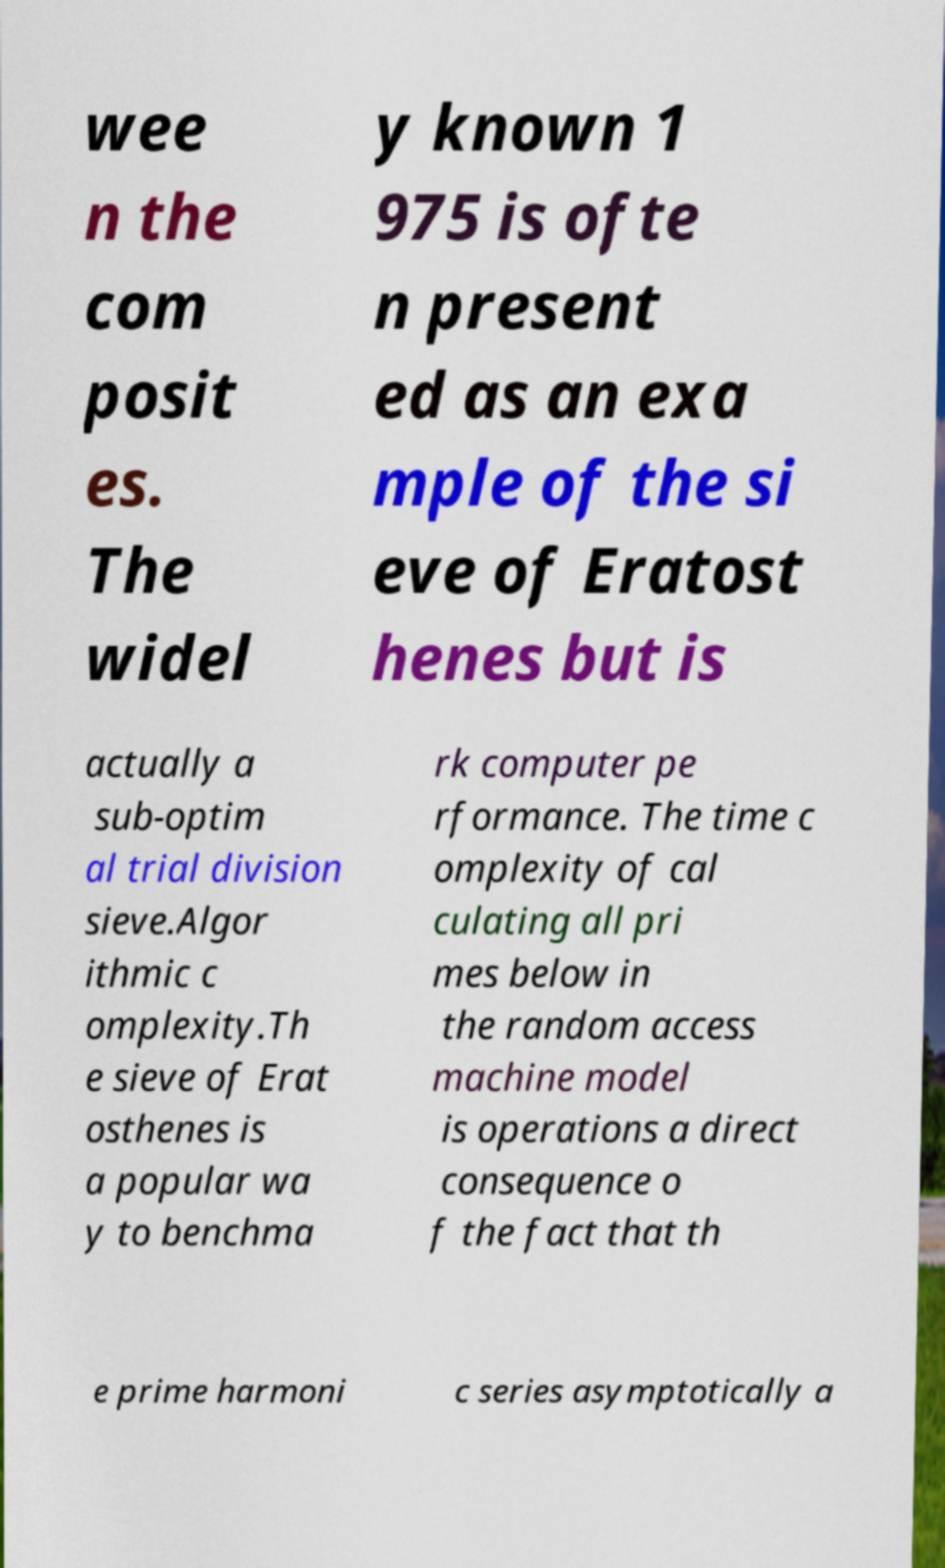Could you extract and type out the text from this image? wee n the com posit es. The widel y known 1 975 is ofte n present ed as an exa mple of the si eve of Eratost henes but is actually a sub-optim al trial division sieve.Algor ithmic c omplexity.Th e sieve of Erat osthenes is a popular wa y to benchma rk computer pe rformance. The time c omplexity of cal culating all pri mes below in the random access machine model is operations a direct consequence o f the fact that th e prime harmoni c series asymptotically a 